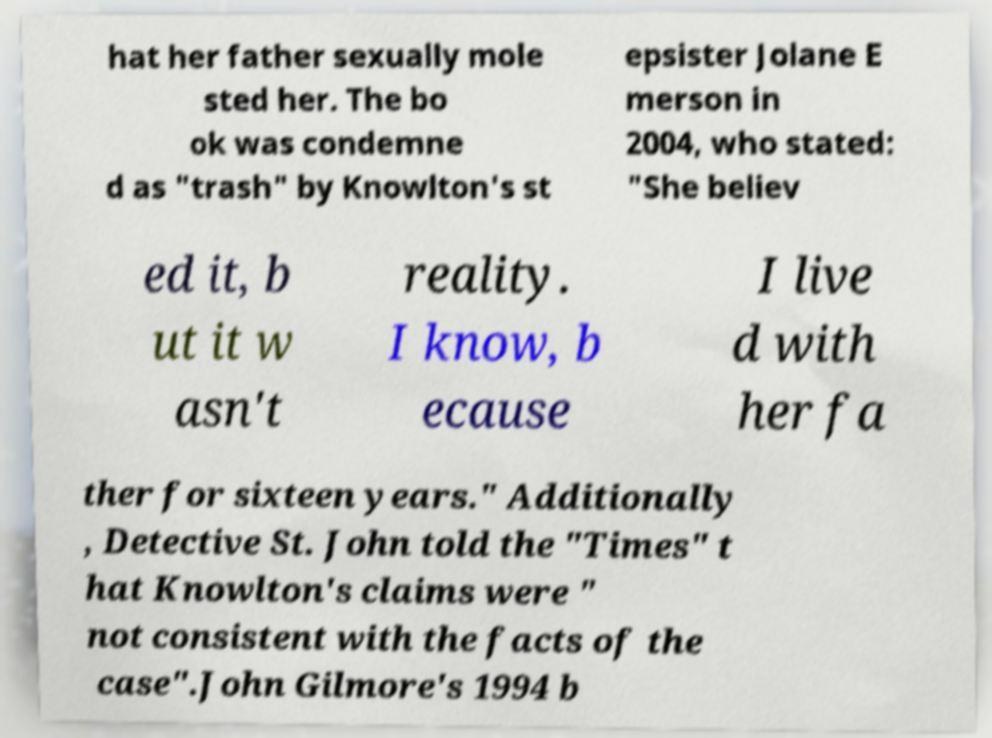Please read and relay the text visible in this image. What does it say? hat her father sexually mole sted her. The bo ok was condemne d as "trash" by Knowlton's st epsister Jolane E merson in 2004, who stated: "She believ ed it, b ut it w asn't reality. I know, b ecause I live d with her fa ther for sixteen years." Additionally , Detective St. John told the "Times" t hat Knowlton's claims were " not consistent with the facts of the case".John Gilmore's 1994 b 